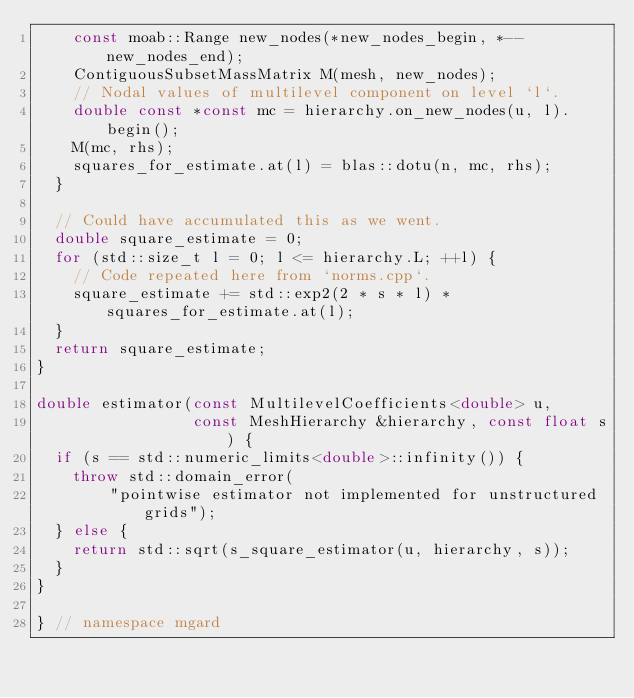Convert code to text. <code><loc_0><loc_0><loc_500><loc_500><_C++_>    const moab::Range new_nodes(*new_nodes_begin, *--new_nodes_end);
    ContiguousSubsetMassMatrix M(mesh, new_nodes);
    // Nodal values of multilevel component on level `l`.
    double const *const mc = hierarchy.on_new_nodes(u, l).begin();
    M(mc, rhs);
    squares_for_estimate.at(l) = blas::dotu(n, mc, rhs);
  }

  // Could have accumulated this as we went.
  double square_estimate = 0;
  for (std::size_t l = 0; l <= hierarchy.L; ++l) {
    // Code repeated here from `norms.cpp`.
    square_estimate += std::exp2(2 * s * l) * squares_for_estimate.at(l);
  }
  return square_estimate;
}

double estimator(const MultilevelCoefficients<double> u,
                 const MeshHierarchy &hierarchy, const float s) {
  if (s == std::numeric_limits<double>::infinity()) {
    throw std::domain_error(
        "pointwise estimator not implemented for unstructured grids");
  } else {
    return std::sqrt(s_square_estimator(u, hierarchy, s));
  }
}

} // namespace mgard
</code> 